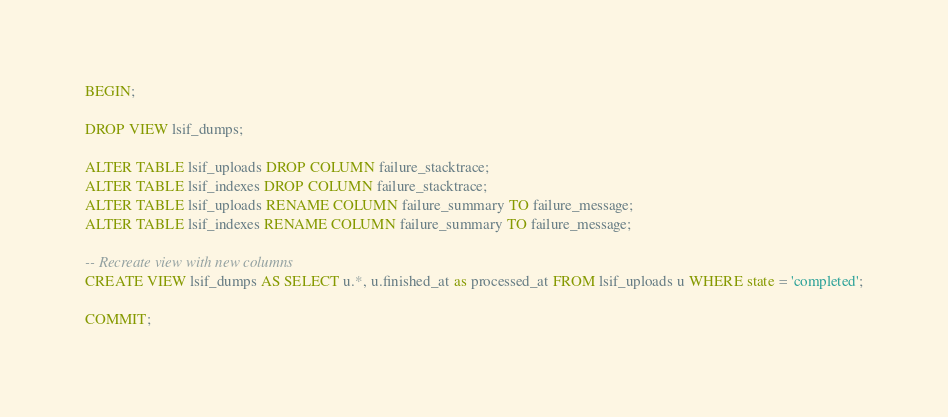<code> <loc_0><loc_0><loc_500><loc_500><_SQL_>BEGIN;

DROP VIEW lsif_dumps;

ALTER TABLE lsif_uploads DROP COLUMN failure_stacktrace;
ALTER TABLE lsif_indexes DROP COLUMN failure_stacktrace;
ALTER TABLE lsif_uploads RENAME COLUMN failure_summary TO failure_message;
ALTER TABLE lsif_indexes RENAME COLUMN failure_summary TO failure_message;

-- Recreate view with new columns
CREATE VIEW lsif_dumps AS SELECT u.*, u.finished_at as processed_at FROM lsif_uploads u WHERE state = 'completed';

COMMIT;
</code> 